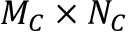Convert formula to latex. <formula><loc_0><loc_0><loc_500><loc_500>M _ { C } \times N _ { C }</formula> 